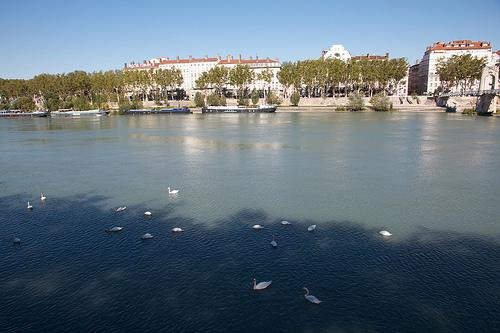Question: how many birds are there on the lake?
Choices:
A. Four.
B. Sixteen.
C. Twelve.
D. One.
Answer with the letter. Answer: B 